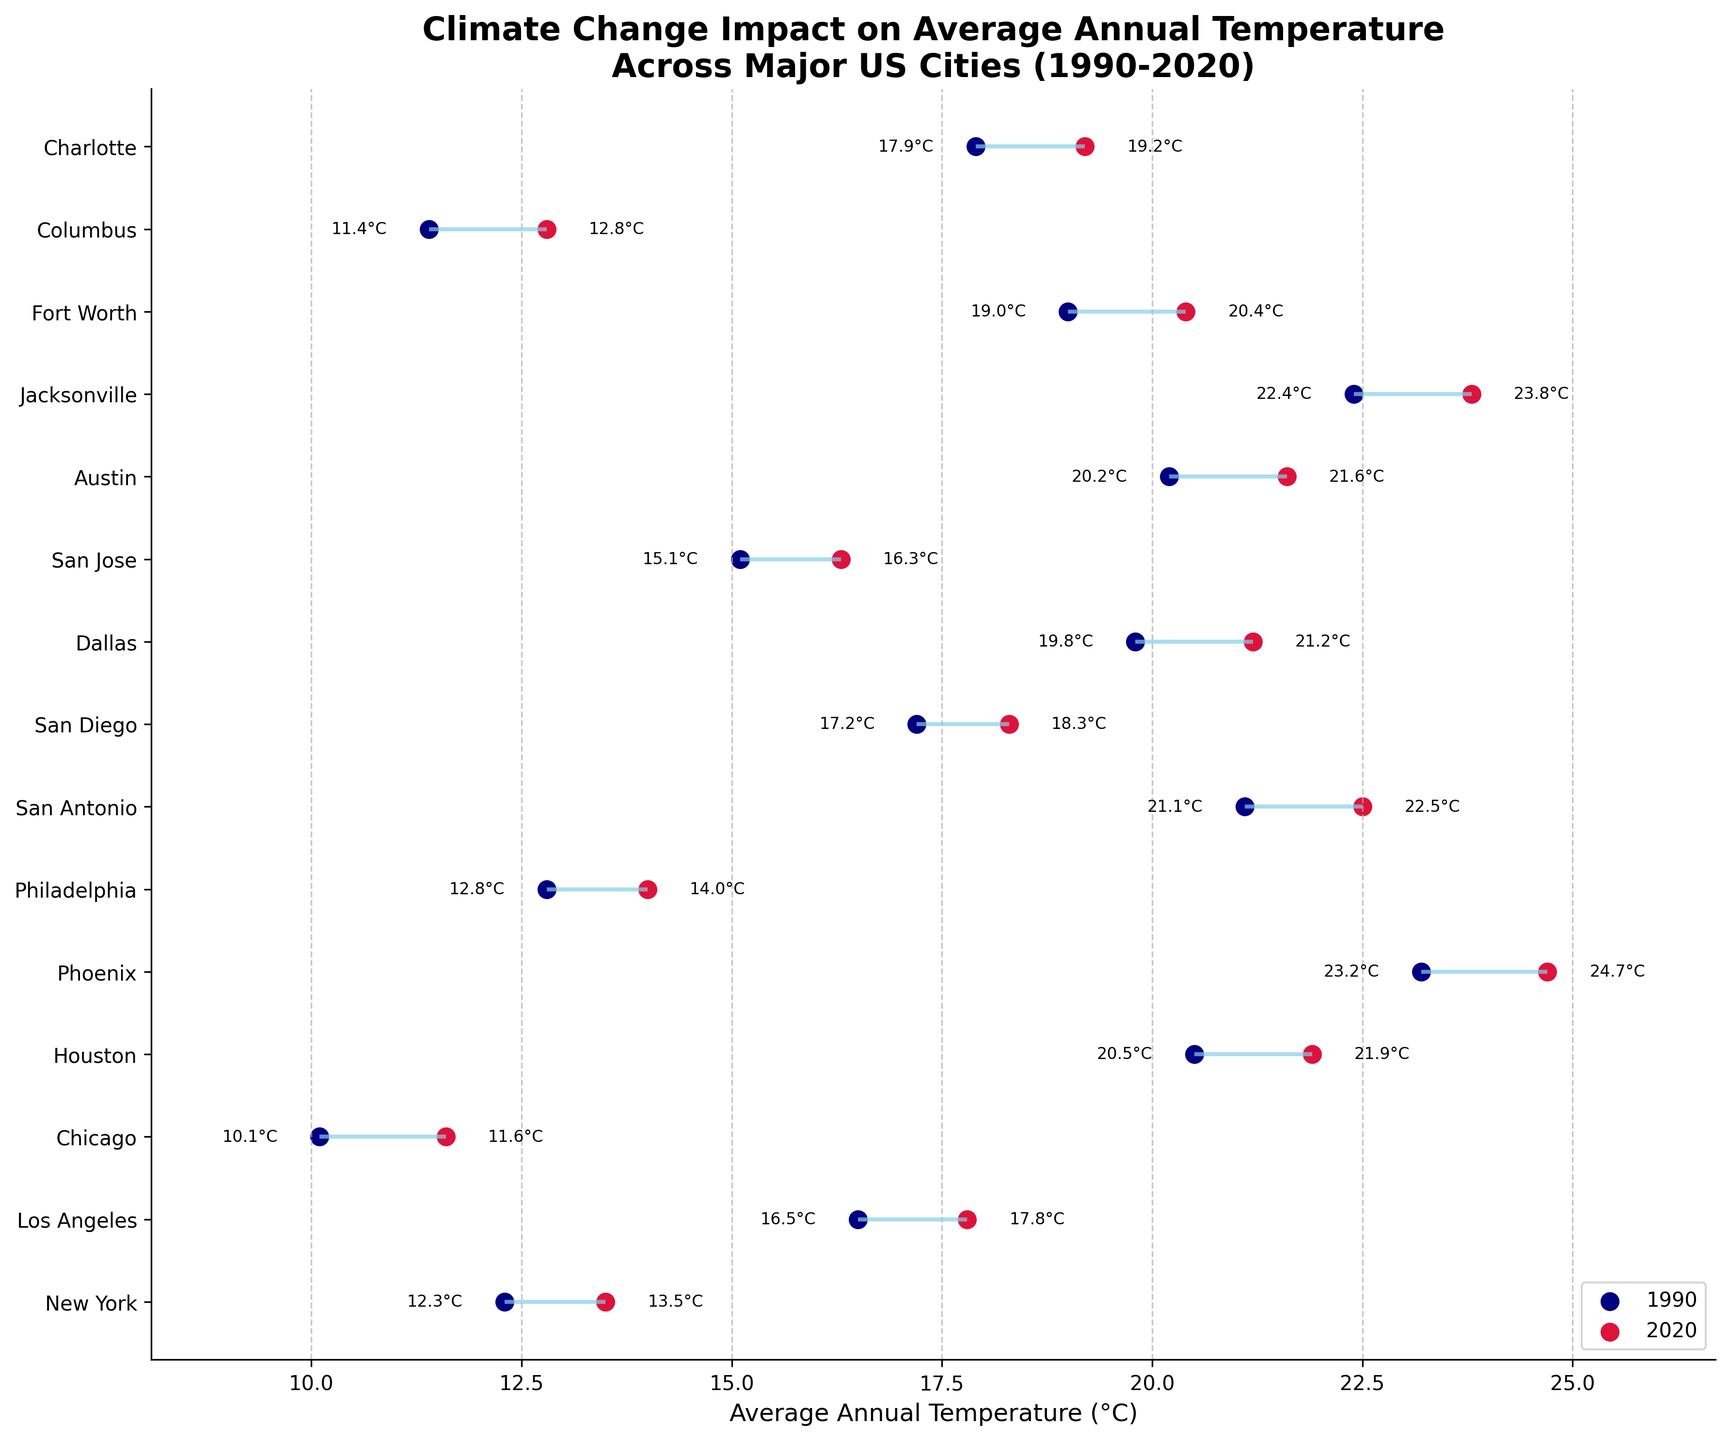What is the title of the plot? The title of the plot is typically placed at the top of the figure in a bold or larger font. In this case, the title is "Climate Change Impact on Average Annual Temperature Across Major US Cities (1990-2020)."
Answer: Climate Change Impact on Average Annual Temperature Across Major US Cities (1990-2020) How many cities are included in the plot? You can count the number of horizontal lines or labeled points on the y-axis to determine the number of cities in the plot. There are 15 horizontal lines, representing 15 cities.
Answer: 15 Which city shows the greatest increase in average annual temperature between 1990 and 2020? To determine the greatest increase, find the city with the longest line from its initial temperature point to its final temperature point. The city with the largest difference is Phoenix, which increased from 23.2°C to 24.7°C (a difference of 1.5°C).
Answer: Phoenix Which city had the highest average annual temperature in 2020? Look at the final points on the right side of the plot. Jacksonville has the highest final temperature at 23.8°C in 2020.
Answer: Jacksonville What is the average final temperature of all the cities in 2020? Add all the final temperatures and divide by the number of cities. The final temperatures are: 13.5, 17.8, 11.6, 21.9, 24.7, 14.0, 22.5, 18.3, 21.2, 16.3, 21.6, 23.8, 20.4, 12.8, 19.2. The sum is 280.6, and there are 15 cities. The average is 280.6/15 = 18.71°C.
Answer: 18.71°C Which city had the lowest average annual temperature in 1990? Look at the initial points on the left side of the plot. Chicago had the lowest initial temperature at 10.1°C in 1990.
Answer: Chicago How much did the average temperature change for Chicago between 1990 and 2020? Calculate the difference between the final temperature and initial temperature for Chicago. The initial temperature was 10.1°C, and the final temperature was 11.6°C. The change is 11.6 - 10.1 = 1.5°C.
Answer: 1.5°C List the cities with an average annual temperature of 21°C or higher in 2020. Identify final points equal to or above 21°C. These cities are Houston (21.9°C), San Antonio (22.5°C), Austin (21.6°C), Jacksonville (23.8°C), and Fort Worth (20.4°C). Note that Dallas slightly misses the threshold at 20.4°C.
Answer: Houston, San Antonio, Austin, Jacksonville Which city had nearly equal initial and final temperatures? Look for cities where the line between initial and final points is very short. San Jose had initial temperature 15.1°C and final temperature 16.3°C, which is a relatively small change of 1.2°C.
Answer: San Jose Which cities had an initial temperature above 20°C in 1990? Identify initial points that are above 20°C. These cities are Houston (20.5°C), Phoenix (23.2°C), San Antonio (21.1°C), Austin (20.2°C), and Jacksonville (22.4°C).
Answer: Houston, Phoenix, San Antonio, Austin, Jacksonville 